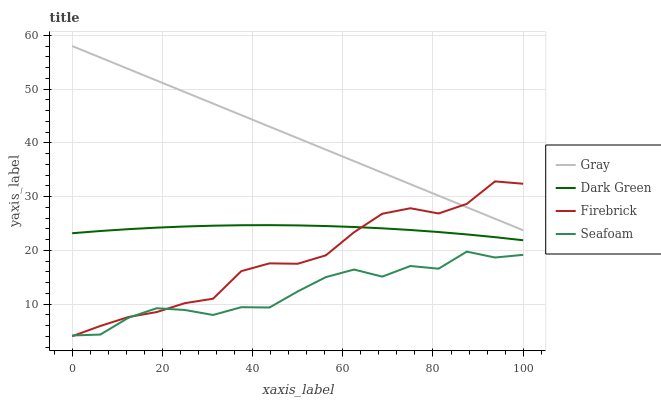Does Seafoam have the minimum area under the curve?
Answer yes or no. Yes. Does Gray have the maximum area under the curve?
Answer yes or no. Yes. Does Firebrick have the minimum area under the curve?
Answer yes or no. No. Does Firebrick have the maximum area under the curve?
Answer yes or no. No. Is Gray the smoothest?
Answer yes or no. Yes. Is Seafoam the roughest?
Answer yes or no. Yes. Is Firebrick the smoothest?
Answer yes or no. No. Is Firebrick the roughest?
Answer yes or no. No. Does Firebrick have the lowest value?
Answer yes or no. Yes. Does Seafoam have the lowest value?
Answer yes or no. No. Does Gray have the highest value?
Answer yes or no. Yes. Does Firebrick have the highest value?
Answer yes or no. No. Is Seafoam less than Gray?
Answer yes or no. Yes. Is Gray greater than Seafoam?
Answer yes or no. Yes. Does Dark Green intersect Firebrick?
Answer yes or no. Yes. Is Dark Green less than Firebrick?
Answer yes or no. No. Is Dark Green greater than Firebrick?
Answer yes or no. No. Does Seafoam intersect Gray?
Answer yes or no. No. 